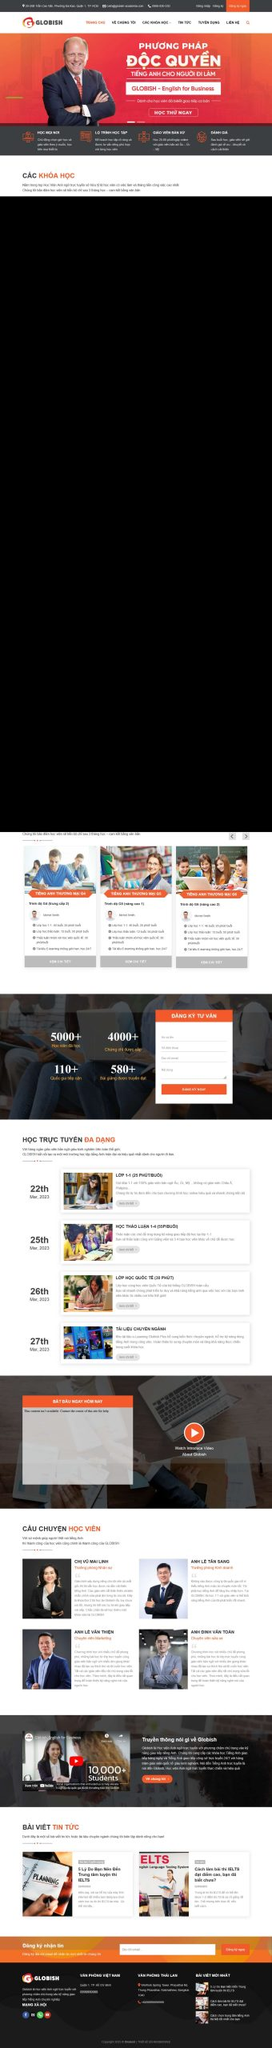Liệt kê 5 ngành nghề, lĩnh vực phù hợp với website này, phân cách các màu sắc bằng dấu phẩy. Chỉ trả về kết quả, phân cách bằng dấy phẩy
 Giáo dục, Đào tạo, Tư vấn, Công nghệ thông tin, Truyền thông 